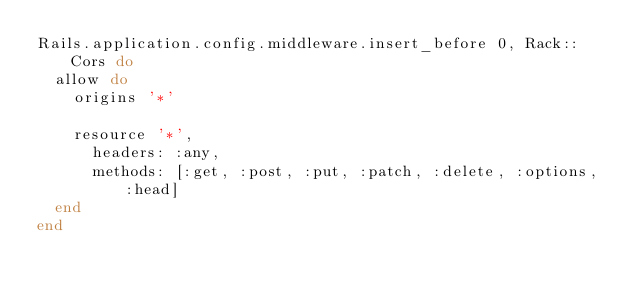Convert code to text. <code><loc_0><loc_0><loc_500><loc_500><_Ruby_>Rails.application.config.middleware.insert_before 0, Rack::Cors do
  allow do
    origins '*'

    resource '*',
      headers: :any,
      methods: [:get, :post, :put, :patch, :delete, :options, :head]
  end
end</code> 